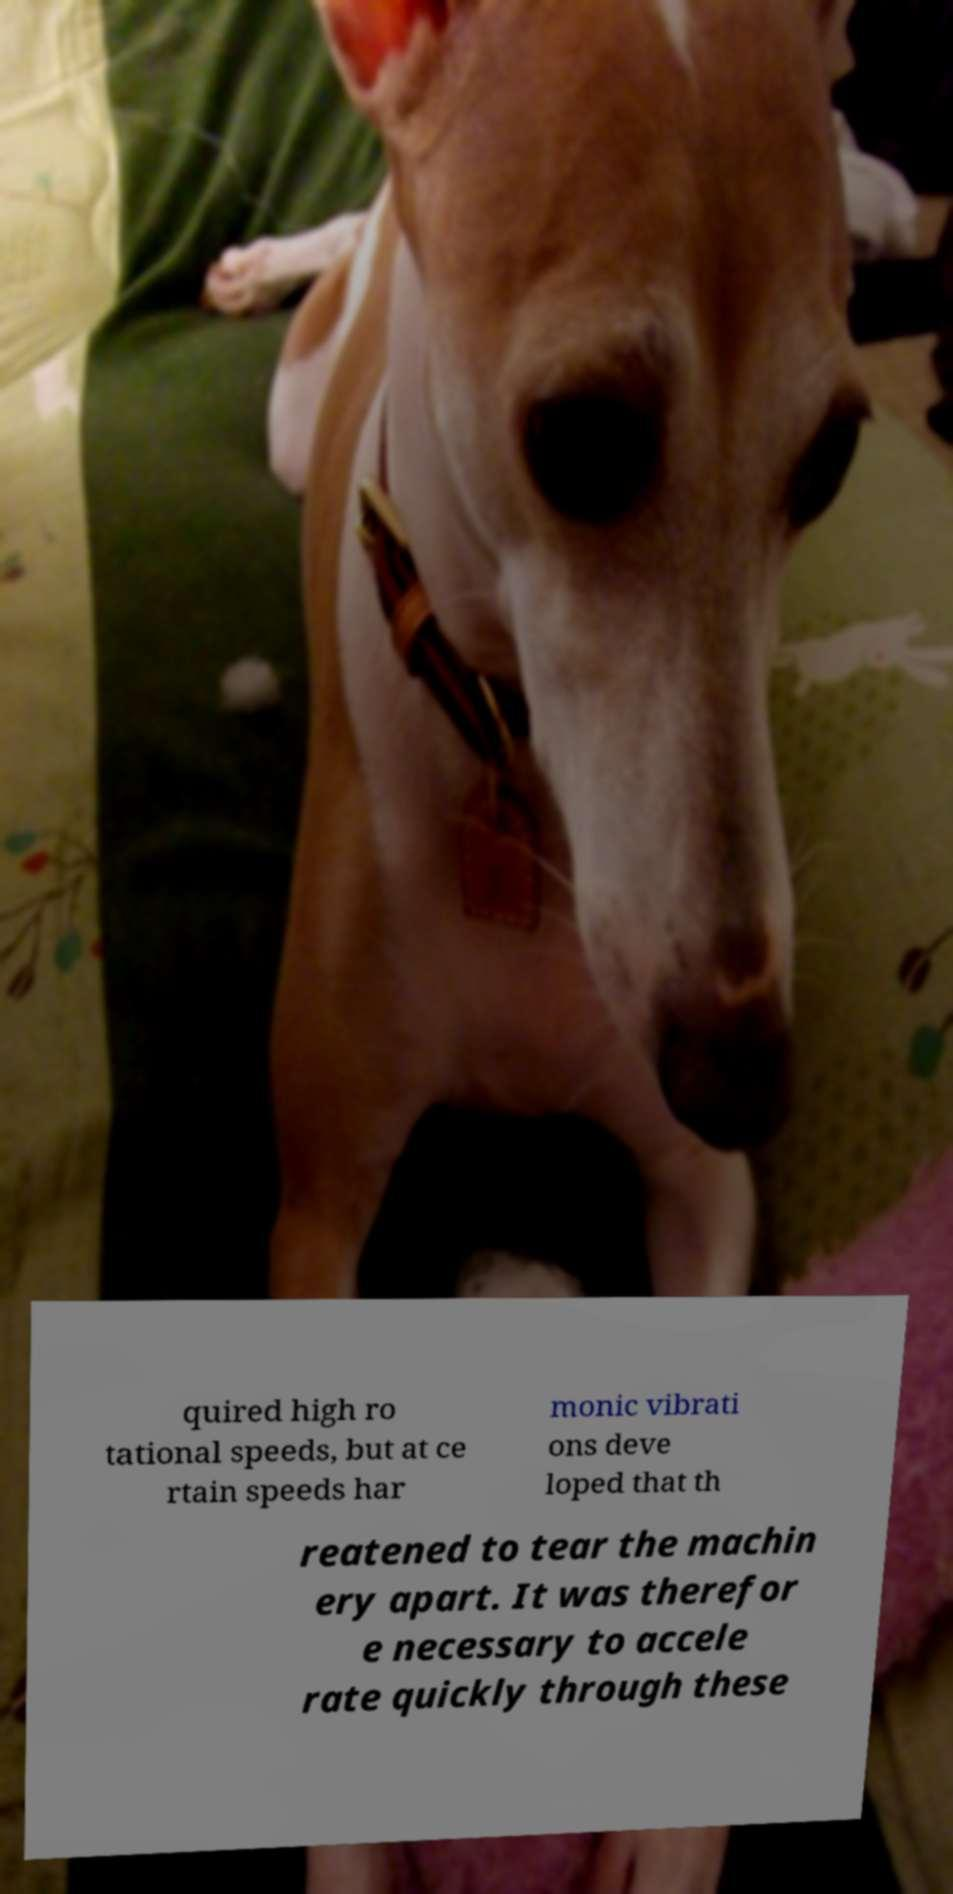There's text embedded in this image that I need extracted. Can you transcribe it verbatim? quired high ro tational speeds, but at ce rtain speeds har monic vibrati ons deve loped that th reatened to tear the machin ery apart. It was therefor e necessary to accele rate quickly through these 